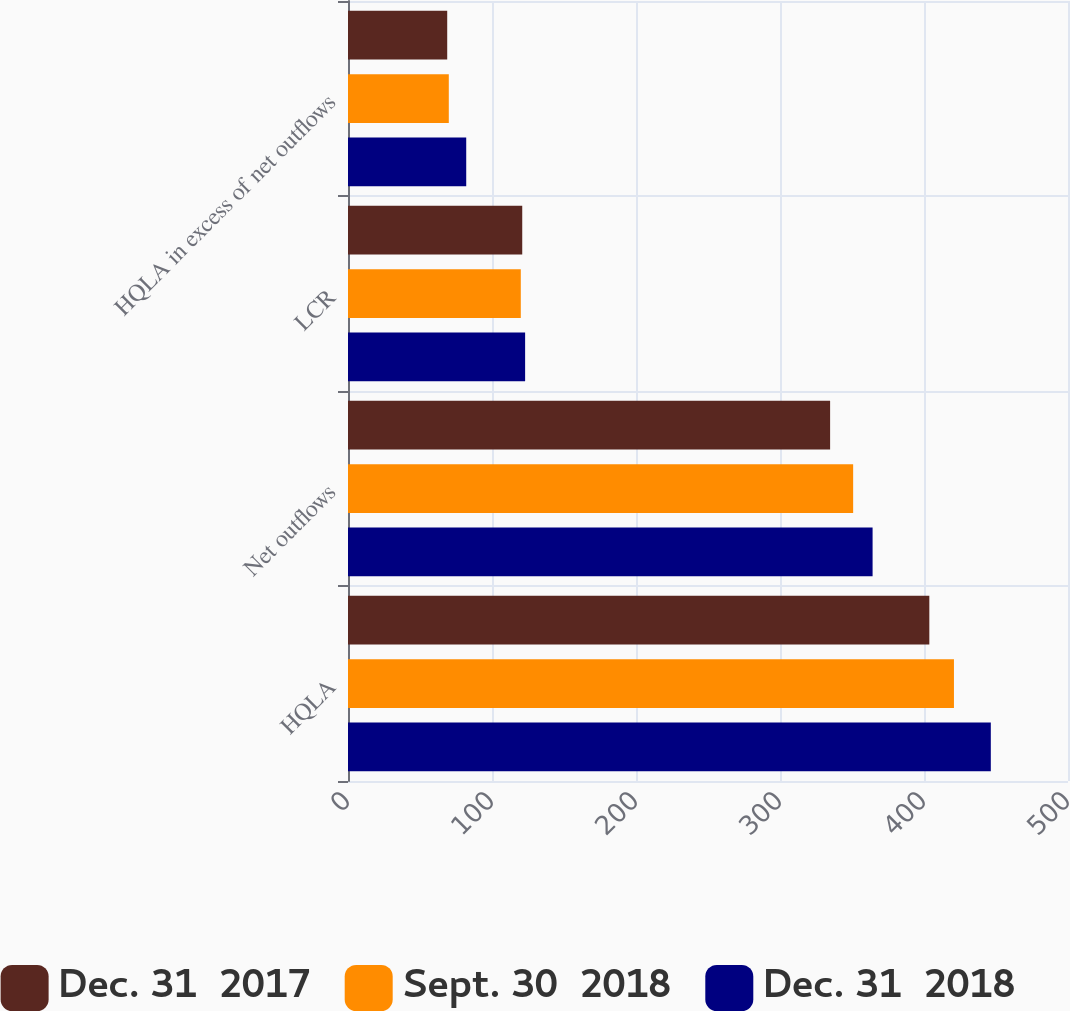Convert chart to OTSL. <chart><loc_0><loc_0><loc_500><loc_500><stacked_bar_chart><ecel><fcel>HQLA<fcel>Net outflows<fcel>LCR<fcel>HQLA in excess of net outflows<nl><fcel>Dec. 31  2017<fcel>403.7<fcel>334.8<fcel>121<fcel>68.9<nl><fcel>Sept. 30  2018<fcel>420.8<fcel>350.8<fcel>120<fcel>70<nl><fcel>Dec. 31  2018<fcel>446.4<fcel>364.3<fcel>123<fcel>82.1<nl></chart> 